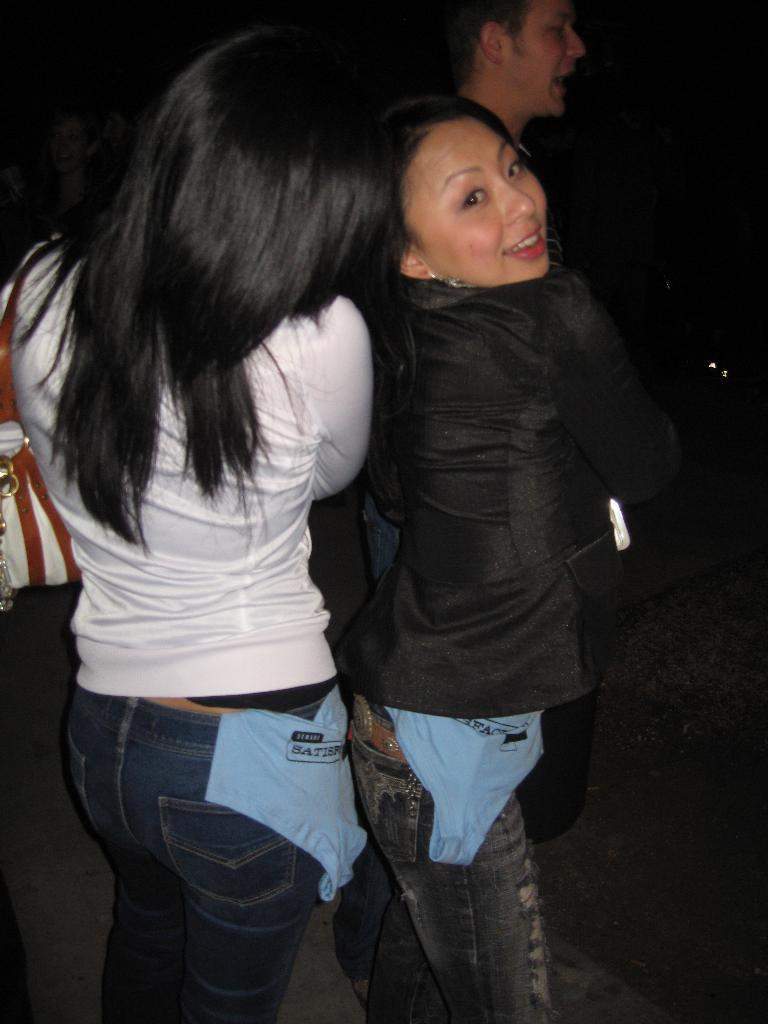Who or what can be seen in the image? There are people in the image. Where are the people located? The people are standing on the road. What type of soup is being served on the road in the image? There is no soup present in the image; it features people standing on the road. Can you see any guns in the image? There are no guns visible in the image. 